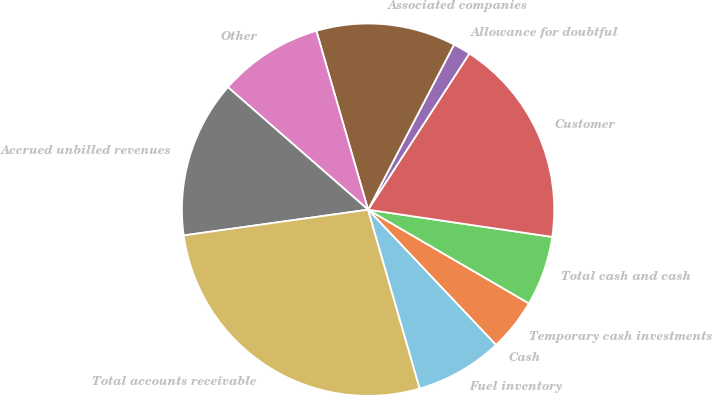Convert chart to OTSL. <chart><loc_0><loc_0><loc_500><loc_500><pie_chart><fcel>Cash<fcel>Temporary cash investments<fcel>Total cash and cash<fcel>Customer<fcel>Allowance for doubtful<fcel>Associated companies<fcel>Other<fcel>Accrued unbilled revenues<fcel>Total accounts receivable<fcel>Fuel inventory<nl><fcel>0.0%<fcel>4.55%<fcel>6.06%<fcel>18.18%<fcel>1.52%<fcel>12.12%<fcel>9.09%<fcel>13.64%<fcel>27.27%<fcel>7.58%<nl></chart> 